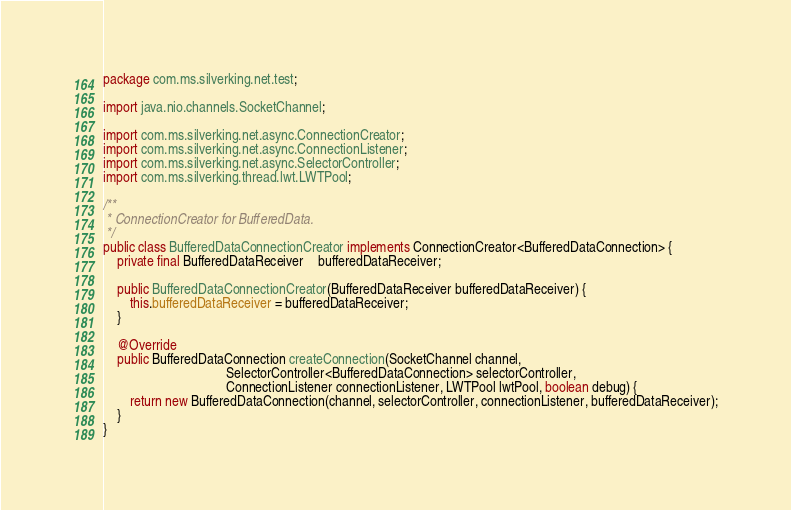Convert code to text. <code><loc_0><loc_0><loc_500><loc_500><_Java_>package com.ms.silverking.net.test;

import java.nio.channels.SocketChannel;

import com.ms.silverking.net.async.ConnectionCreator;
import com.ms.silverking.net.async.ConnectionListener;
import com.ms.silverking.net.async.SelectorController;
import com.ms.silverking.thread.lwt.LWTPool;

/**
 * ConnectionCreator for BufferedData.
 */
public class BufferedDataConnectionCreator implements ConnectionCreator<BufferedDataConnection> {
    private final BufferedDataReceiver    bufferedDataReceiver;
    
    public BufferedDataConnectionCreator(BufferedDataReceiver bufferedDataReceiver) {
        this.bufferedDataReceiver = bufferedDataReceiver;
    }
    
    @Override
    public BufferedDataConnection createConnection(SocketChannel channel, 
                                    SelectorController<BufferedDataConnection> selectorController,
                                    ConnectionListener connectionListener, LWTPool lwtPool, boolean debug) {
        return new BufferedDataConnection(channel, selectorController, connectionListener, bufferedDataReceiver);
    }
}
</code> 